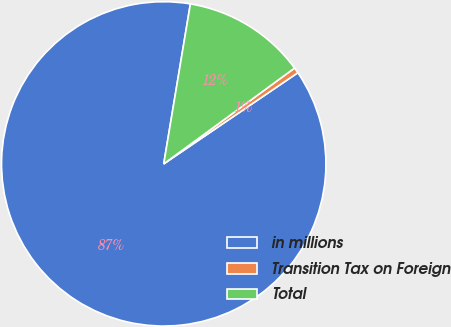Convert chart to OTSL. <chart><loc_0><loc_0><loc_500><loc_500><pie_chart><fcel>in millions<fcel>Transition Tax on Foreign<fcel>Total<nl><fcel>87.13%<fcel>0.56%<fcel>12.31%<nl></chart> 